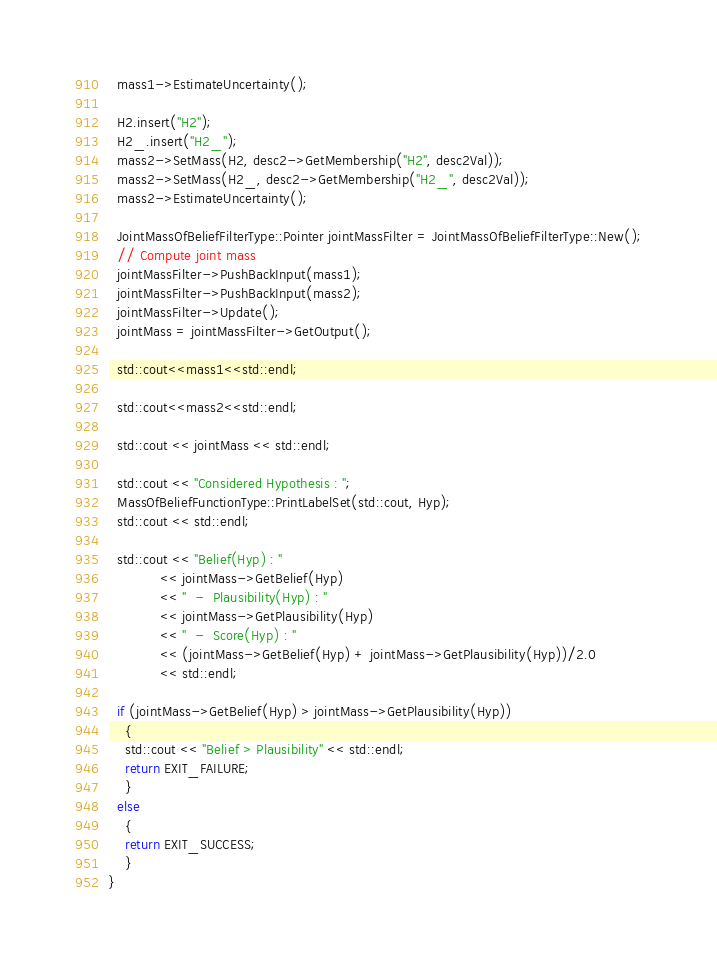Convert code to text. <code><loc_0><loc_0><loc_500><loc_500><_C++_>  mass1->EstimateUncertainty();

  H2.insert("H2");
  H2_.insert("H2_");
  mass2->SetMass(H2, desc2->GetMembership("H2", desc2Val));
  mass2->SetMass(H2_, desc2->GetMembership("H2_", desc2Val));
  mass2->EstimateUncertainty();

  JointMassOfBeliefFilterType::Pointer jointMassFilter = JointMassOfBeliefFilterType::New();
  // Compute joint mass
  jointMassFilter->PushBackInput(mass1);
  jointMassFilter->PushBackInput(mass2);
  jointMassFilter->Update();
  jointMass = jointMassFilter->GetOutput();

  std::cout<<mass1<<std::endl;

  std::cout<<mass2<<std::endl;

  std::cout << jointMass << std::endl;
  
  std::cout << "Considered Hypothesis : ";
  MassOfBeliefFunctionType::PrintLabelSet(std::cout, Hyp);
  std::cout << std::endl;
  
  std::cout << "Belief(Hyp) : "
            << jointMass->GetBelief(Hyp)
            << "  -  Plausibility(Hyp) : "
            << jointMass->GetPlausibility(Hyp)
            << "  -  Score(Hyp) : "
            << (jointMass->GetBelief(Hyp) + jointMass->GetPlausibility(Hyp))/2.0
            << std::endl;

  if (jointMass->GetBelief(Hyp) > jointMass->GetPlausibility(Hyp))
    {
    std::cout << "Belief > Plausibility" << std::endl;
    return EXIT_FAILURE;
    }
  else
    {
    return EXIT_SUCCESS;
    }
}
</code> 